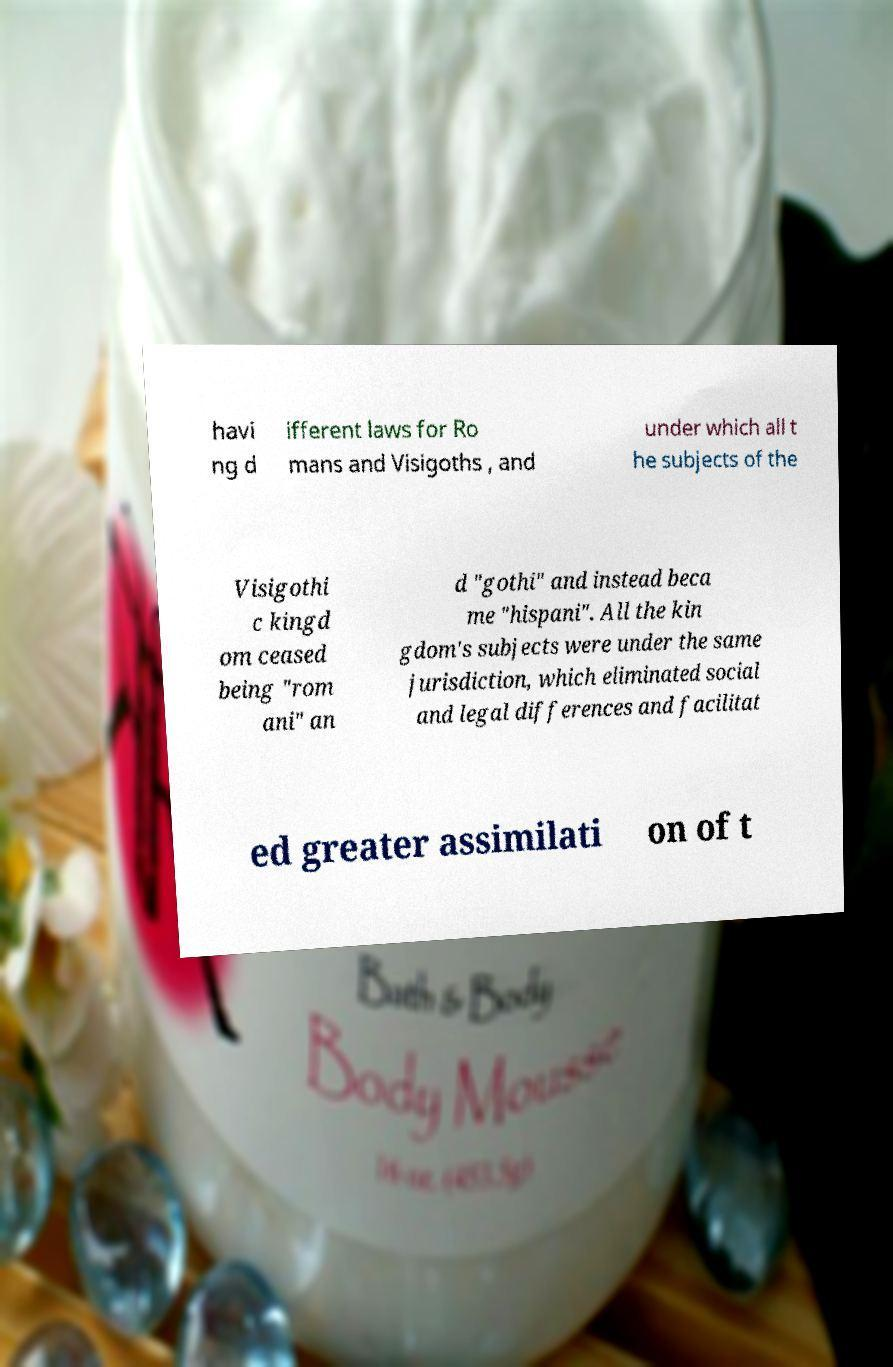Could you assist in decoding the text presented in this image and type it out clearly? havi ng d ifferent laws for Ro mans and Visigoths , and under which all t he subjects of the Visigothi c kingd om ceased being "rom ani" an d "gothi" and instead beca me "hispani". All the kin gdom's subjects were under the same jurisdiction, which eliminated social and legal differences and facilitat ed greater assimilati on of t 